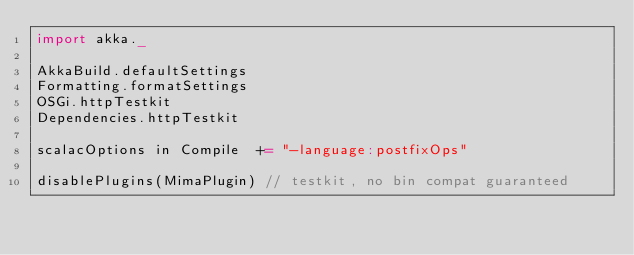<code> <loc_0><loc_0><loc_500><loc_500><_Scala_>import akka._

AkkaBuild.defaultSettings
Formatting.formatSettings
OSGi.httpTestkit
Dependencies.httpTestkit

scalacOptions in Compile  += "-language:postfixOps"

disablePlugins(MimaPlugin) // testkit, no bin compat guaranteed
</code> 